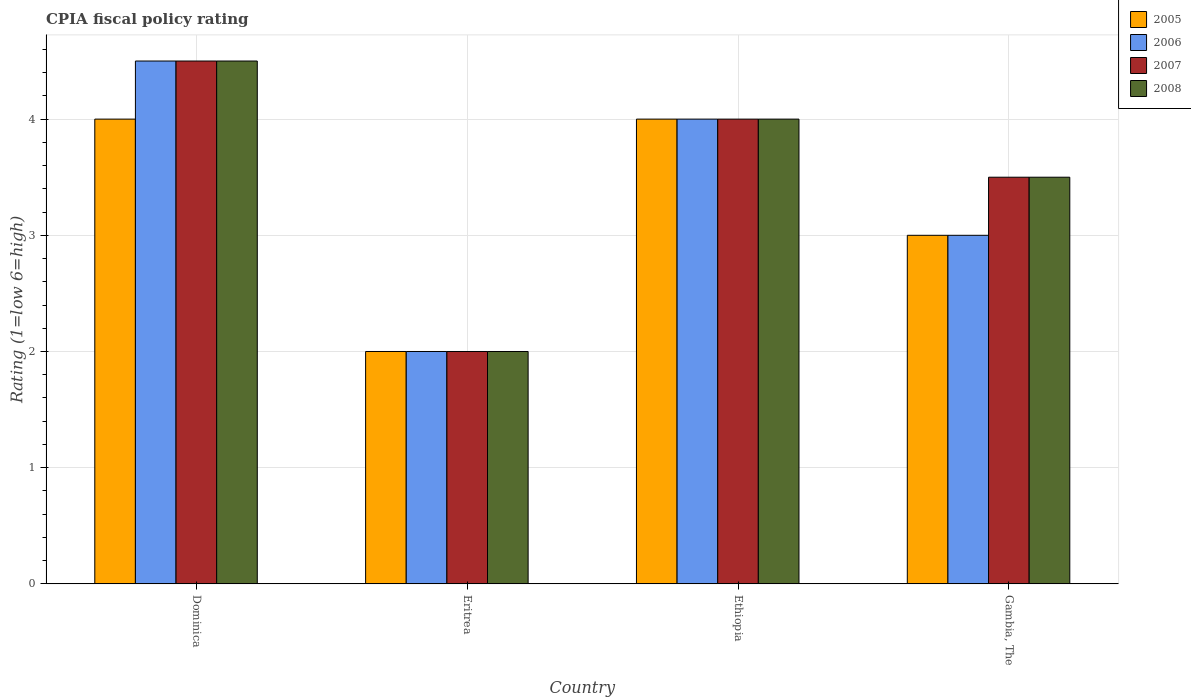How many different coloured bars are there?
Offer a terse response. 4. Are the number of bars per tick equal to the number of legend labels?
Provide a short and direct response. Yes. Are the number of bars on each tick of the X-axis equal?
Ensure brevity in your answer.  Yes. How many bars are there on the 2nd tick from the left?
Give a very brief answer. 4. How many bars are there on the 3rd tick from the right?
Provide a short and direct response. 4. What is the label of the 1st group of bars from the left?
Ensure brevity in your answer.  Dominica. In which country was the CPIA rating in 2006 maximum?
Ensure brevity in your answer.  Dominica. In which country was the CPIA rating in 2008 minimum?
Offer a terse response. Eritrea. What is the total CPIA rating in 2008 in the graph?
Offer a terse response. 14. What is the difference between the CPIA rating in 2007 in Dominica and that in Eritrea?
Provide a short and direct response. 2.5. What is the difference between the CPIA rating in 2008 in Gambia, The and the CPIA rating in 2007 in Ethiopia?
Keep it short and to the point. -0.5. What is the average CPIA rating in 2005 per country?
Your answer should be compact. 3.25. What is the difference between the CPIA rating of/in 2007 and CPIA rating of/in 2008 in Eritrea?
Your response must be concise. 0. In how many countries, is the CPIA rating in 2006 greater than 1.8?
Give a very brief answer. 4. Is the CPIA rating in 2005 in Dominica less than that in Gambia, The?
Ensure brevity in your answer.  No. Is the difference between the CPIA rating in 2007 in Ethiopia and Gambia, The greater than the difference between the CPIA rating in 2008 in Ethiopia and Gambia, The?
Give a very brief answer. No. What is the difference between the highest and the second highest CPIA rating in 2008?
Ensure brevity in your answer.  -1. Is it the case that in every country, the sum of the CPIA rating in 2005 and CPIA rating in 2007 is greater than the sum of CPIA rating in 2006 and CPIA rating in 2008?
Your answer should be very brief. No. What does the 4th bar from the right in Ethiopia represents?
Your answer should be very brief. 2005. Are all the bars in the graph horizontal?
Give a very brief answer. No. How many countries are there in the graph?
Your answer should be compact. 4. What is the difference between two consecutive major ticks on the Y-axis?
Keep it short and to the point. 1. Are the values on the major ticks of Y-axis written in scientific E-notation?
Keep it short and to the point. No. Where does the legend appear in the graph?
Offer a very short reply. Top right. How are the legend labels stacked?
Offer a very short reply. Vertical. What is the title of the graph?
Ensure brevity in your answer.  CPIA fiscal policy rating. What is the label or title of the X-axis?
Offer a very short reply. Country. What is the Rating (1=low 6=high) of 2005 in Dominica?
Your answer should be very brief. 4. What is the Rating (1=low 6=high) in 2007 in Dominica?
Your response must be concise. 4.5. What is the Rating (1=low 6=high) of 2006 in Eritrea?
Provide a succinct answer. 2. What is the Rating (1=low 6=high) in 2008 in Eritrea?
Your answer should be very brief. 2. What is the Rating (1=low 6=high) in 2005 in Ethiopia?
Offer a terse response. 4. What is the Rating (1=low 6=high) of 2007 in Gambia, The?
Your answer should be compact. 3.5. What is the Rating (1=low 6=high) in 2008 in Gambia, The?
Provide a succinct answer. 3.5. Across all countries, what is the maximum Rating (1=low 6=high) of 2008?
Ensure brevity in your answer.  4.5. Across all countries, what is the minimum Rating (1=low 6=high) of 2008?
Your response must be concise. 2. What is the total Rating (1=low 6=high) of 2006 in the graph?
Your response must be concise. 13.5. What is the total Rating (1=low 6=high) of 2007 in the graph?
Your response must be concise. 14. What is the difference between the Rating (1=low 6=high) of 2005 in Dominica and that in Eritrea?
Your answer should be very brief. 2. What is the difference between the Rating (1=low 6=high) in 2006 in Dominica and that in Eritrea?
Your answer should be very brief. 2.5. What is the difference between the Rating (1=low 6=high) in 2007 in Dominica and that in Eritrea?
Your answer should be compact. 2.5. What is the difference between the Rating (1=low 6=high) of 2007 in Dominica and that in Ethiopia?
Offer a very short reply. 0.5. What is the difference between the Rating (1=low 6=high) of 2008 in Dominica and that in Ethiopia?
Keep it short and to the point. 0.5. What is the difference between the Rating (1=low 6=high) of 2005 in Dominica and that in Gambia, The?
Provide a short and direct response. 1. What is the difference between the Rating (1=low 6=high) in 2006 in Dominica and that in Gambia, The?
Offer a very short reply. 1.5. What is the difference between the Rating (1=low 6=high) of 2007 in Dominica and that in Gambia, The?
Provide a short and direct response. 1. What is the difference between the Rating (1=low 6=high) of 2005 in Eritrea and that in Ethiopia?
Keep it short and to the point. -2. What is the difference between the Rating (1=low 6=high) in 2006 in Eritrea and that in Ethiopia?
Make the answer very short. -2. What is the difference between the Rating (1=low 6=high) of 2008 in Eritrea and that in Ethiopia?
Give a very brief answer. -2. What is the difference between the Rating (1=low 6=high) in 2005 in Eritrea and that in Gambia, The?
Your response must be concise. -1. What is the difference between the Rating (1=low 6=high) in 2006 in Eritrea and that in Gambia, The?
Provide a short and direct response. -1. What is the difference between the Rating (1=low 6=high) of 2008 in Eritrea and that in Gambia, The?
Provide a short and direct response. -1.5. What is the difference between the Rating (1=low 6=high) of 2006 in Ethiopia and that in Gambia, The?
Ensure brevity in your answer.  1. What is the difference between the Rating (1=low 6=high) of 2007 in Ethiopia and that in Gambia, The?
Give a very brief answer. 0.5. What is the difference between the Rating (1=low 6=high) of 2005 in Dominica and the Rating (1=low 6=high) of 2007 in Eritrea?
Offer a very short reply. 2. What is the difference between the Rating (1=low 6=high) in 2005 in Dominica and the Rating (1=low 6=high) in 2008 in Eritrea?
Your answer should be compact. 2. What is the difference between the Rating (1=low 6=high) of 2006 in Dominica and the Rating (1=low 6=high) of 2007 in Eritrea?
Offer a very short reply. 2.5. What is the difference between the Rating (1=low 6=high) of 2006 in Dominica and the Rating (1=low 6=high) of 2008 in Eritrea?
Offer a terse response. 2.5. What is the difference between the Rating (1=low 6=high) in 2005 in Dominica and the Rating (1=low 6=high) in 2006 in Ethiopia?
Ensure brevity in your answer.  0. What is the difference between the Rating (1=low 6=high) of 2005 in Dominica and the Rating (1=low 6=high) of 2007 in Gambia, The?
Offer a very short reply. 0.5. What is the difference between the Rating (1=low 6=high) in 2006 in Dominica and the Rating (1=low 6=high) in 2007 in Gambia, The?
Offer a terse response. 1. What is the difference between the Rating (1=low 6=high) in 2006 in Dominica and the Rating (1=low 6=high) in 2008 in Gambia, The?
Keep it short and to the point. 1. What is the difference between the Rating (1=low 6=high) in 2007 in Dominica and the Rating (1=low 6=high) in 2008 in Gambia, The?
Ensure brevity in your answer.  1. What is the difference between the Rating (1=low 6=high) in 2005 in Eritrea and the Rating (1=low 6=high) in 2007 in Ethiopia?
Your response must be concise. -2. What is the difference between the Rating (1=low 6=high) in 2006 in Eritrea and the Rating (1=low 6=high) in 2007 in Ethiopia?
Give a very brief answer. -2. What is the difference between the Rating (1=low 6=high) in 2007 in Eritrea and the Rating (1=low 6=high) in 2008 in Ethiopia?
Your answer should be compact. -2. What is the difference between the Rating (1=low 6=high) of 2005 in Eritrea and the Rating (1=low 6=high) of 2006 in Gambia, The?
Your answer should be compact. -1. What is the difference between the Rating (1=low 6=high) of 2006 in Eritrea and the Rating (1=low 6=high) of 2007 in Gambia, The?
Keep it short and to the point. -1.5. What is the difference between the Rating (1=low 6=high) of 2005 in Ethiopia and the Rating (1=low 6=high) of 2007 in Gambia, The?
Provide a short and direct response. 0.5. What is the difference between the Rating (1=low 6=high) of 2006 in Ethiopia and the Rating (1=low 6=high) of 2007 in Gambia, The?
Your answer should be very brief. 0.5. What is the difference between the Rating (1=low 6=high) of 2006 in Ethiopia and the Rating (1=low 6=high) of 2008 in Gambia, The?
Your answer should be very brief. 0.5. What is the average Rating (1=low 6=high) of 2005 per country?
Provide a short and direct response. 3.25. What is the average Rating (1=low 6=high) in 2006 per country?
Your answer should be compact. 3.38. What is the average Rating (1=low 6=high) in 2007 per country?
Keep it short and to the point. 3.5. What is the average Rating (1=low 6=high) of 2008 per country?
Your answer should be compact. 3.5. What is the difference between the Rating (1=low 6=high) in 2005 and Rating (1=low 6=high) in 2008 in Dominica?
Offer a very short reply. -0.5. What is the difference between the Rating (1=low 6=high) in 2006 and Rating (1=low 6=high) in 2008 in Dominica?
Give a very brief answer. 0. What is the difference between the Rating (1=low 6=high) of 2006 and Rating (1=low 6=high) of 2007 in Eritrea?
Provide a succinct answer. 0. What is the difference between the Rating (1=low 6=high) in 2007 and Rating (1=low 6=high) in 2008 in Eritrea?
Provide a short and direct response. 0. What is the difference between the Rating (1=low 6=high) of 2005 and Rating (1=low 6=high) of 2007 in Ethiopia?
Your answer should be very brief. 0. What is the difference between the Rating (1=low 6=high) in 2006 and Rating (1=low 6=high) in 2007 in Ethiopia?
Provide a succinct answer. 0. What is the difference between the Rating (1=low 6=high) in 2006 and Rating (1=low 6=high) in 2008 in Ethiopia?
Provide a short and direct response. 0. What is the difference between the Rating (1=low 6=high) of 2007 and Rating (1=low 6=high) of 2008 in Ethiopia?
Offer a terse response. 0. What is the difference between the Rating (1=low 6=high) in 2005 and Rating (1=low 6=high) in 2006 in Gambia, The?
Your answer should be compact. 0. What is the difference between the Rating (1=low 6=high) in 2005 and Rating (1=low 6=high) in 2007 in Gambia, The?
Your answer should be compact. -0.5. What is the difference between the Rating (1=low 6=high) of 2006 and Rating (1=low 6=high) of 2007 in Gambia, The?
Your answer should be very brief. -0.5. What is the ratio of the Rating (1=low 6=high) in 2005 in Dominica to that in Eritrea?
Make the answer very short. 2. What is the ratio of the Rating (1=low 6=high) in 2006 in Dominica to that in Eritrea?
Offer a terse response. 2.25. What is the ratio of the Rating (1=low 6=high) of 2007 in Dominica to that in Eritrea?
Make the answer very short. 2.25. What is the ratio of the Rating (1=low 6=high) in 2008 in Dominica to that in Eritrea?
Keep it short and to the point. 2.25. What is the ratio of the Rating (1=low 6=high) in 2008 in Dominica to that in Gambia, The?
Your answer should be very brief. 1.29. What is the ratio of the Rating (1=low 6=high) in 2005 in Eritrea to that in Ethiopia?
Provide a short and direct response. 0.5. What is the ratio of the Rating (1=low 6=high) in 2006 in Eritrea to that in Ethiopia?
Keep it short and to the point. 0.5. What is the ratio of the Rating (1=low 6=high) of 2007 in Eritrea to that in Ethiopia?
Give a very brief answer. 0.5. What is the ratio of the Rating (1=low 6=high) of 2005 in Eritrea to that in Gambia, The?
Your response must be concise. 0.67. What is the ratio of the Rating (1=low 6=high) of 2006 in Eritrea to that in Gambia, The?
Your response must be concise. 0.67. What is the ratio of the Rating (1=low 6=high) of 2008 in Eritrea to that in Gambia, The?
Keep it short and to the point. 0.57. What is the ratio of the Rating (1=low 6=high) in 2005 in Ethiopia to that in Gambia, The?
Your answer should be very brief. 1.33. What is the ratio of the Rating (1=low 6=high) of 2006 in Ethiopia to that in Gambia, The?
Make the answer very short. 1.33. What is the ratio of the Rating (1=low 6=high) in 2007 in Ethiopia to that in Gambia, The?
Offer a very short reply. 1.14. What is the difference between the highest and the second highest Rating (1=low 6=high) of 2007?
Your response must be concise. 0.5. What is the difference between the highest and the lowest Rating (1=low 6=high) of 2007?
Ensure brevity in your answer.  2.5. 